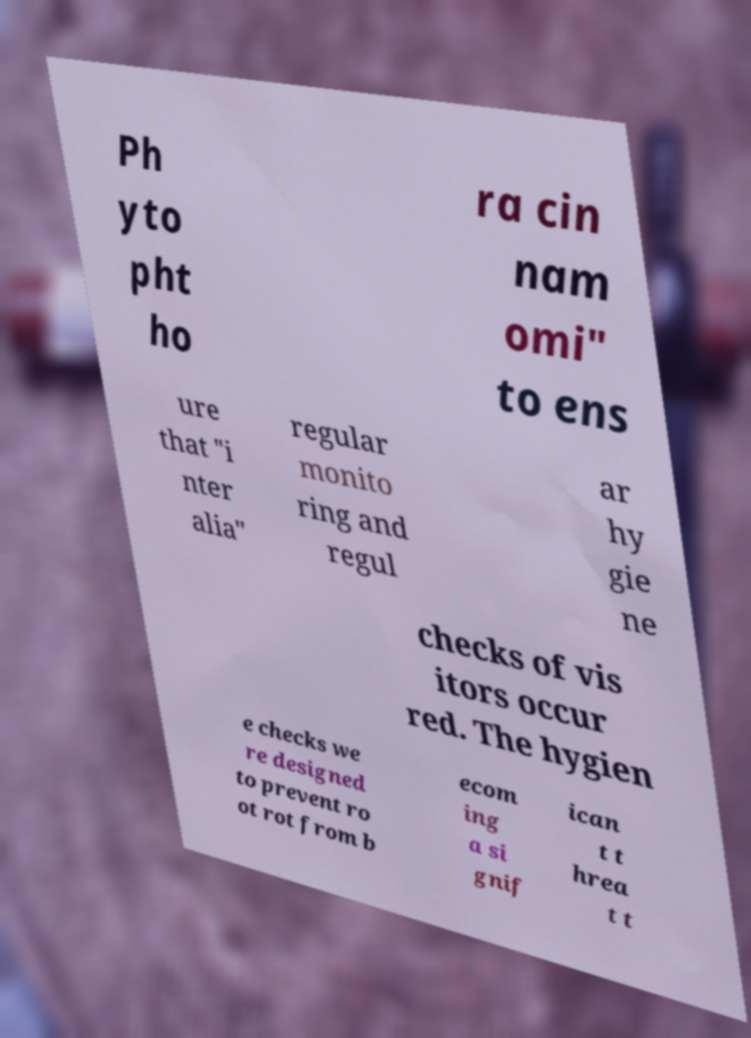What messages or text are displayed in this image? I need them in a readable, typed format. Ph yto pht ho ra cin nam omi" to ens ure that "i nter alia" regular monito ring and regul ar hy gie ne checks of vis itors occur red. The hygien e checks we re designed to prevent ro ot rot from b ecom ing a si gnif ican t t hrea t t 